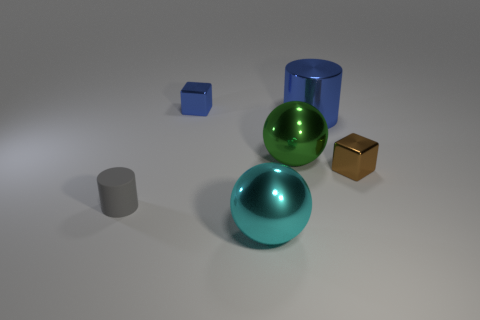Is there any other thing that is made of the same material as the tiny cylinder?
Keep it short and to the point. No. How many objects are either tiny things that are on the right side of the tiny gray object or green objects behind the cyan shiny object?
Your answer should be compact. 3. What is the color of the other metallic thing that is the same shape as the tiny blue metal object?
Provide a succinct answer. Brown. Does the large green thing have the same shape as the cyan object that is to the left of the large metallic cylinder?
Provide a succinct answer. Yes. What is the tiny brown cube made of?
Offer a terse response. Metal. What is the size of the other metallic thing that is the same shape as the big green object?
Provide a short and direct response. Large. What number of other things are the same material as the gray cylinder?
Offer a very short reply. 0. Is the material of the small brown object the same as the cylinder that is behind the gray cylinder?
Your response must be concise. Yes. Are there fewer blocks on the right side of the blue cube than cyan shiny balls on the right side of the small matte thing?
Keep it short and to the point. No. What is the color of the ball that is in front of the brown shiny thing?
Ensure brevity in your answer.  Cyan. 